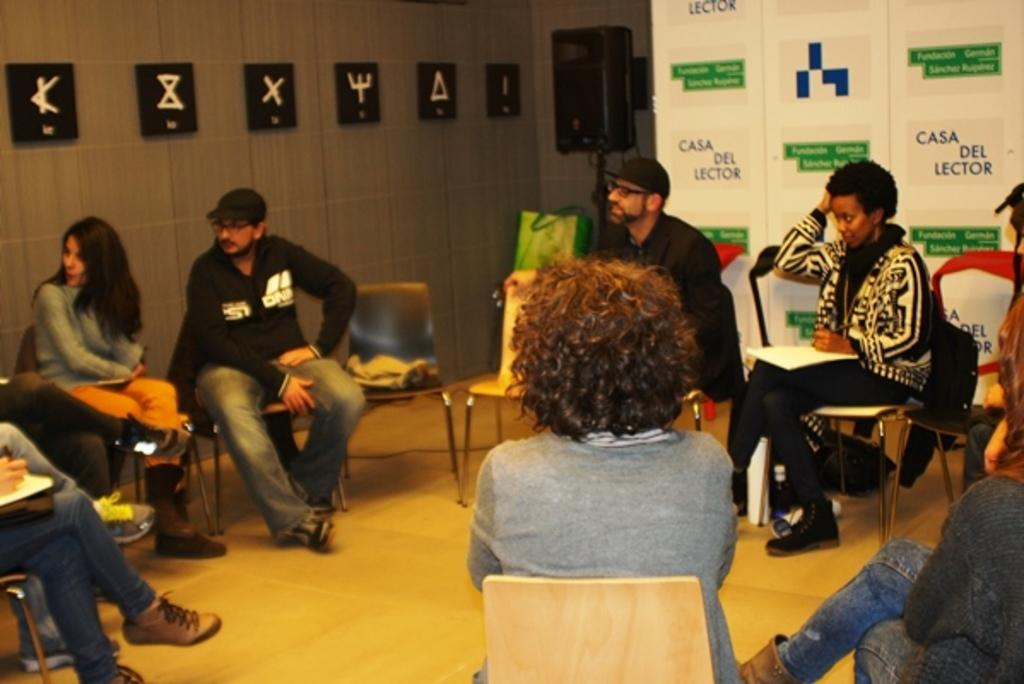What are the people in the image doing? There are persons sitting in the image. What can be seen in the background of the image? There are banners with text and frames on the wall in the background of the image. What type of temper does the kitten have in the image? There is no kitten present in the image, so it is not possible to determine its temper. 